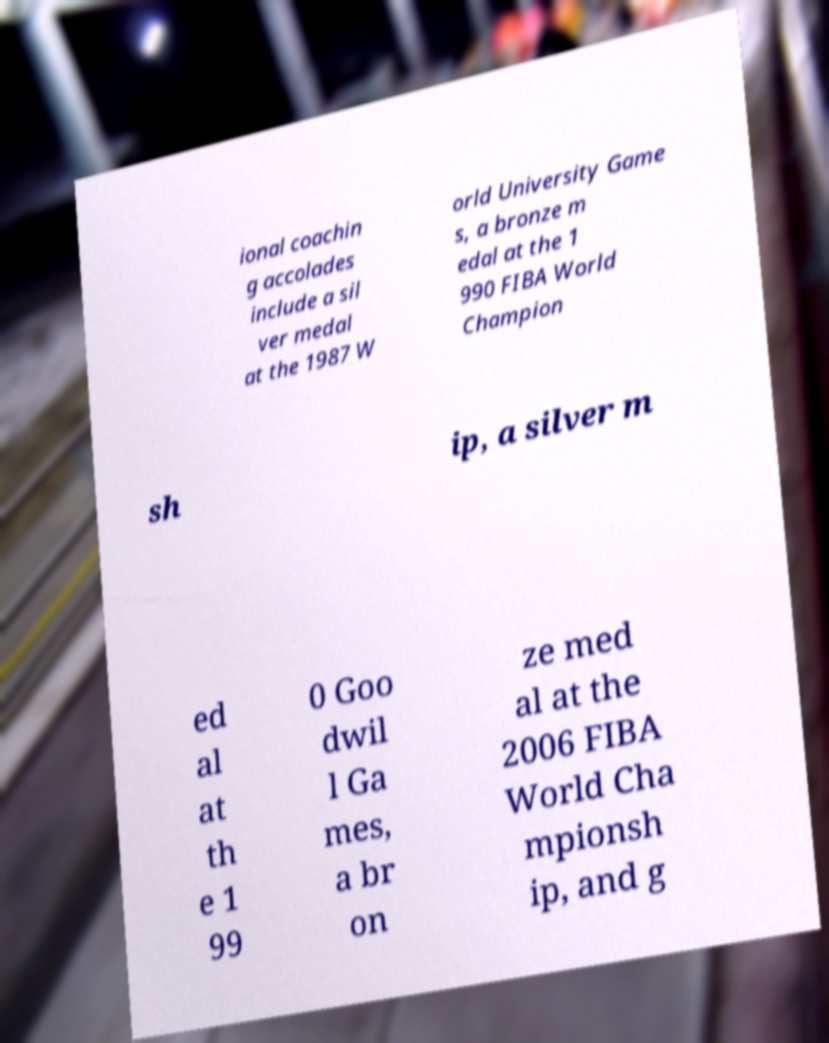Can you read and provide the text displayed in the image?This photo seems to have some interesting text. Can you extract and type it out for me? ional coachin g accolades include a sil ver medal at the 1987 W orld University Game s, a bronze m edal at the 1 990 FIBA World Champion sh ip, a silver m ed al at th e 1 99 0 Goo dwil l Ga mes, a br on ze med al at the 2006 FIBA World Cha mpionsh ip, and g 